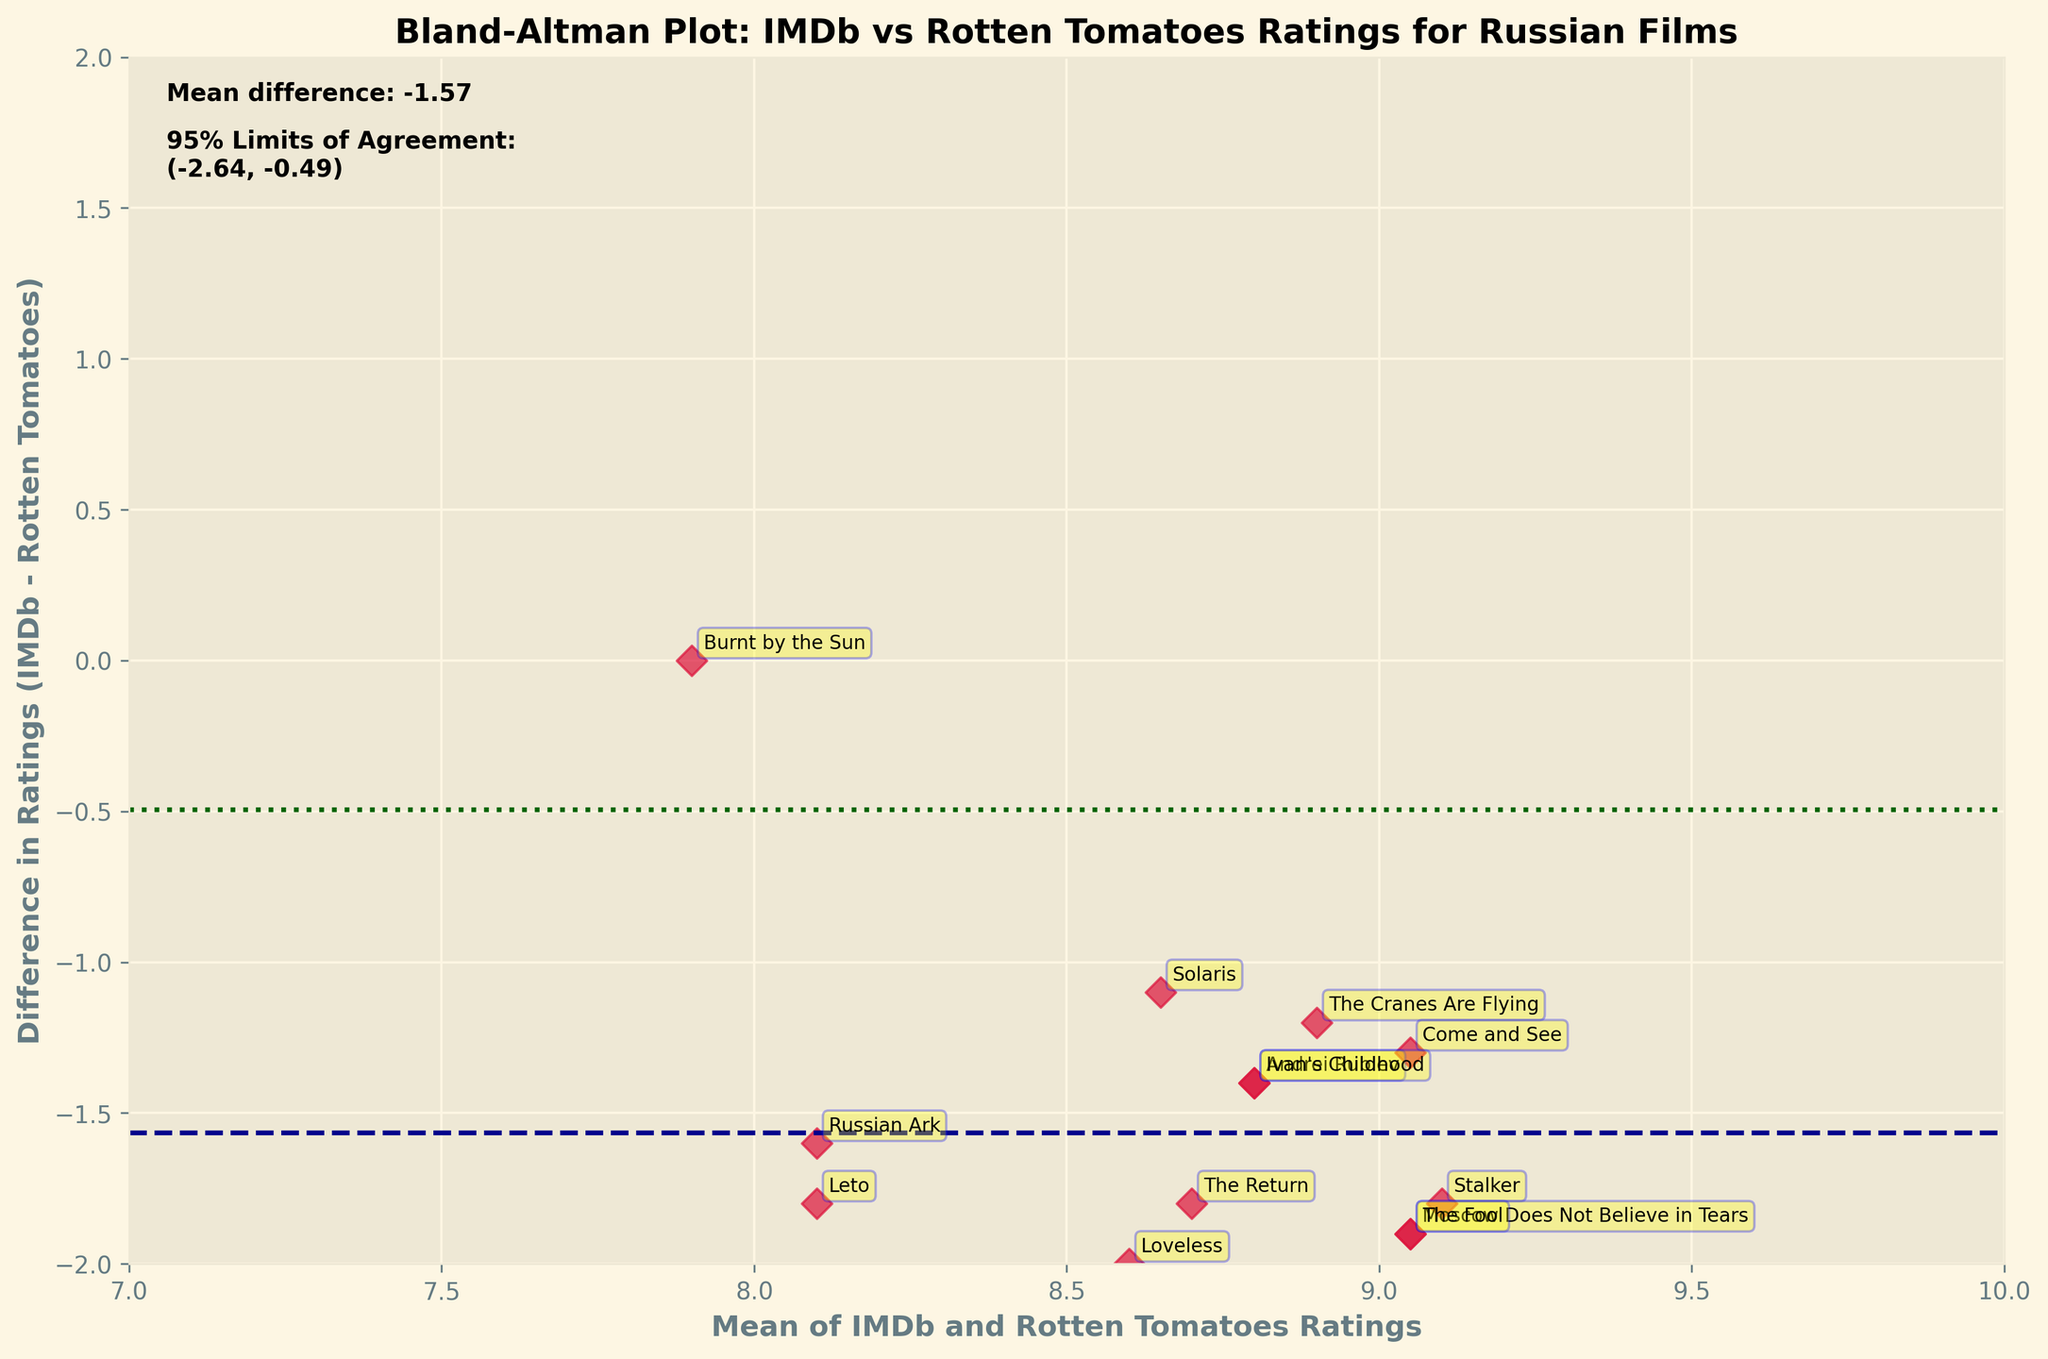What are the mean and difference axes labeled as? The x-axis on the plot is labeled "Mean of IMDb and Rotten Tomatoes Ratings," while the y-axis is labeled "Difference in Ratings (IMDb - Rotten Tomatoes)."
Answer: Mean of IMDb and Rotten Tomatoes Ratings, Difference in Ratings (IMDb - Rotten Tomatoes) What is the title of the figure? The title of the figure, as shown at the top of the plot in bold, is "Bland-Altman Plot: IMDb vs Rotten Tomatoes Ratings for Russian Films."
Answer: Bland-Altman Plot: IMDb vs Rotten Tomatoes Ratings for Russian Films How many data points are plotted on the figure? There are 15 movies in the data, and each one is represented as a point on the plot, so there are 15 data points in total.
Answer: 15 Which movie has the highest difference between IMDb and Rotten Tomatoes ratings? The movie "Russian Ark" has the highest difference, as indicated by its position farthest from the x-axis along the y-axis.
Answer: Russian Ark What are the 95% limits of agreement shown in the plot? The 95% limits of agreement are displayed as horizontal dotted lines, and the text on the plot indicates these limits as approximately (-1.94, 0.91).
Answer: (-1.94, 0.91) What's the range of the x-axis? The x-axis range is set from 7 to 10, which is determined by the plot limits shown.
Answer: 7 to 10 What's the average difference between IMDb and Rotten Tomatoes ratings across all movies? The plot includes a dashed horizontal line showing the mean difference, and the text indicates this value is around -0.51.
Answer: -0.51 Which movie's rating difference is closest to 0? The movie "Stalker" is closest to the x-axis, indicating its rating difference is nearly zero.
Answer: Stalker Are there more movies with higher IMDb ratings or Rotten Tomatoes ratings? Most points are below the mean difference line, indicating IMDb ratings are generally lower than Rotten Tomatoes ratings for these movies.
Answer: Rotten Tomatoes ratings Which movie has the lowest mean rating? By identifying the leftmost point on the plot, we see that "Beanpole" has the lowest mean rating.
Answer: Beanpole 